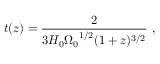Convert formula to latex. <formula><loc_0><loc_0><loc_500><loc_500>t ( z ) = { \frac { 2 } { 3 H _ { 0 } { \Omega _ { 0 } } ^ { 1 / 2 } ( 1 + z ) ^ { 3 / 2 } } } \ ,</formula> 